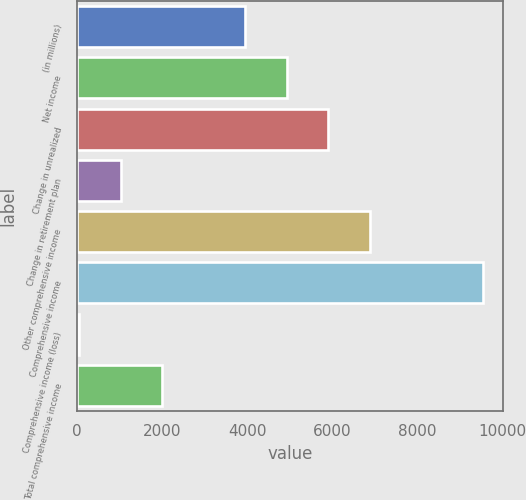Convert chart. <chart><loc_0><loc_0><loc_500><loc_500><bar_chart><fcel>(in millions)<fcel>Net income<fcel>Change in unrealized<fcel>Change in retirement plan<fcel>Other comprehensive income<fcel>Comprehensive income<fcel>Comprehensive income (loss)<fcel>Total comprehensive income<nl><fcel>3952.6<fcel>4926.5<fcel>5900.4<fcel>1030.9<fcel>6874.3<fcel>9531<fcel>57<fcel>2004.8<nl></chart> 